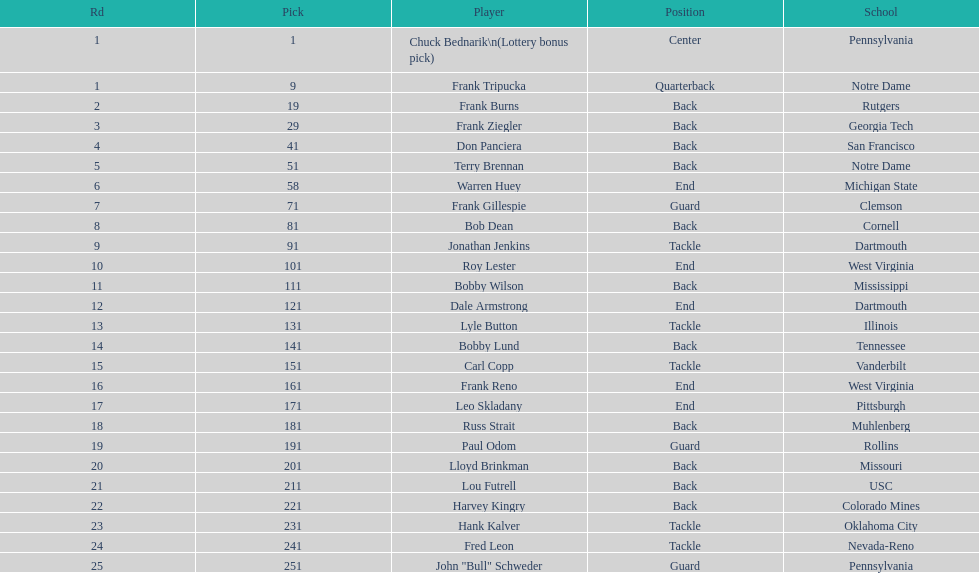What is the highest number in rd? 25. 